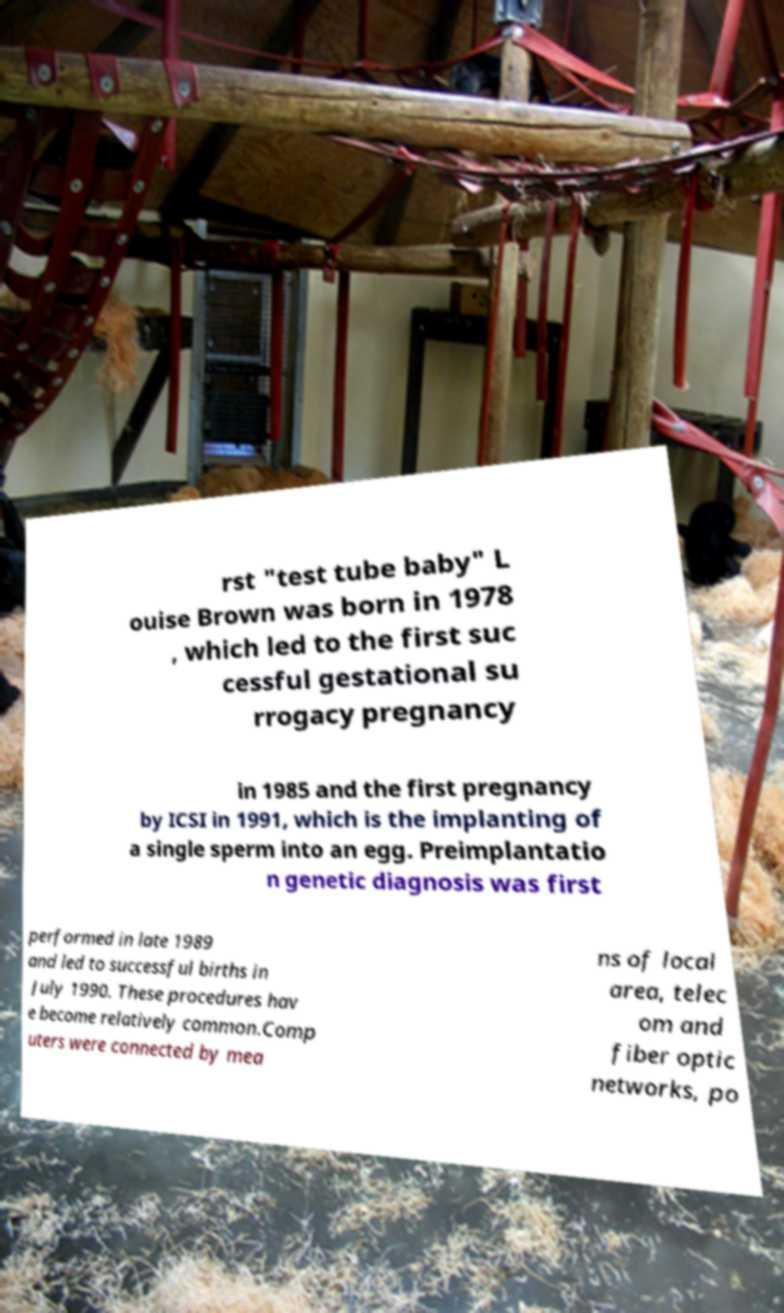Can you read and provide the text displayed in the image?This photo seems to have some interesting text. Can you extract and type it out for me? rst "test tube baby" L ouise Brown was born in 1978 , which led to the first suc cessful gestational su rrogacy pregnancy in 1985 and the first pregnancy by ICSI in 1991, which is the implanting of a single sperm into an egg. Preimplantatio n genetic diagnosis was first performed in late 1989 and led to successful births in July 1990. These procedures hav e become relatively common.Comp uters were connected by mea ns of local area, telec om and fiber optic networks, po 